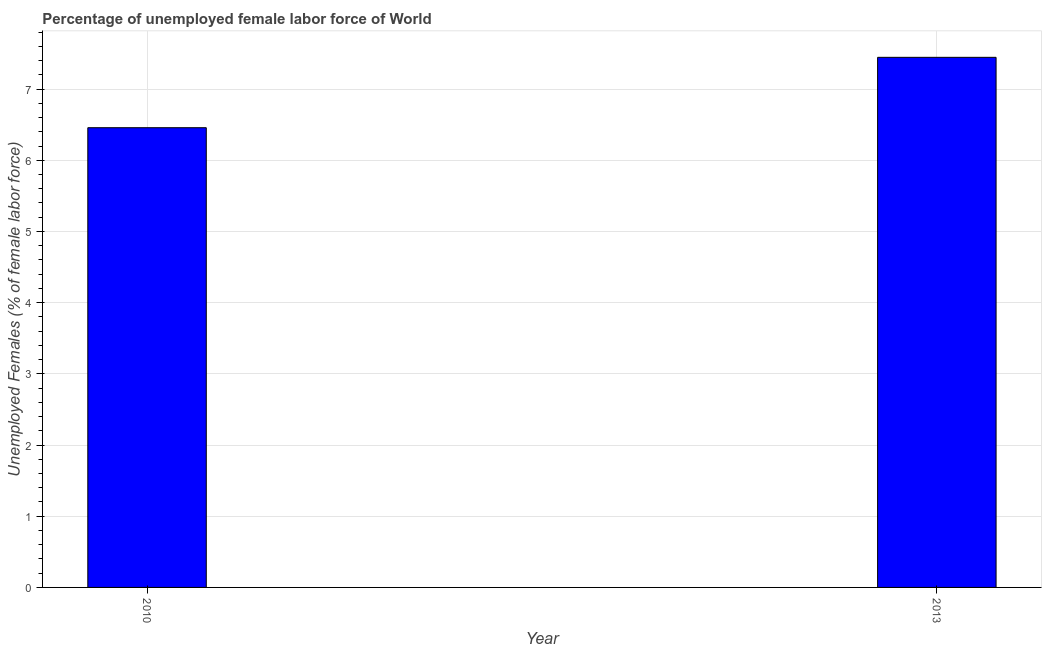Does the graph contain grids?
Your answer should be very brief. Yes. What is the title of the graph?
Give a very brief answer. Percentage of unemployed female labor force of World. What is the label or title of the Y-axis?
Ensure brevity in your answer.  Unemployed Females (% of female labor force). What is the total unemployed female labour force in 2010?
Provide a short and direct response. 6.46. Across all years, what is the maximum total unemployed female labour force?
Ensure brevity in your answer.  7.45. Across all years, what is the minimum total unemployed female labour force?
Offer a very short reply. 6.46. In which year was the total unemployed female labour force maximum?
Make the answer very short. 2013. In which year was the total unemployed female labour force minimum?
Your response must be concise. 2010. What is the sum of the total unemployed female labour force?
Ensure brevity in your answer.  13.9. What is the difference between the total unemployed female labour force in 2010 and 2013?
Keep it short and to the point. -0.99. What is the average total unemployed female labour force per year?
Provide a succinct answer. 6.95. What is the median total unemployed female labour force?
Ensure brevity in your answer.  6.95. In how many years, is the total unemployed female labour force greater than 1.2 %?
Your answer should be compact. 2. What is the ratio of the total unemployed female labour force in 2010 to that in 2013?
Make the answer very short. 0.87. Is the total unemployed female labour force in 2010 less than that in 2013?
Offer a very short reply. Yes. How many bars are there?
Your answer should be very brief. 2. How many years are there in the graph?
Your answer should be compact. 2. Are the values on the major ticks of Y-axis written in scientific E-notation?
Your response must be concise. No. What is the Unemployed Females (% of female labor force) of 2010?
Provide a short and direct response. 6.46. What is the Unemployed Females (% of female labor force) in 2013?
Your answer should be compact. 7.45. What is the difference between the Unemployed Females (% of female labor force) in 2010 and 2013?
Offer a very short reply. -0.99. What is the ratio of the Unemployed Females (% of female labor force) in 2010 to that in 2013?
Offer a very short reply. 0.87. 